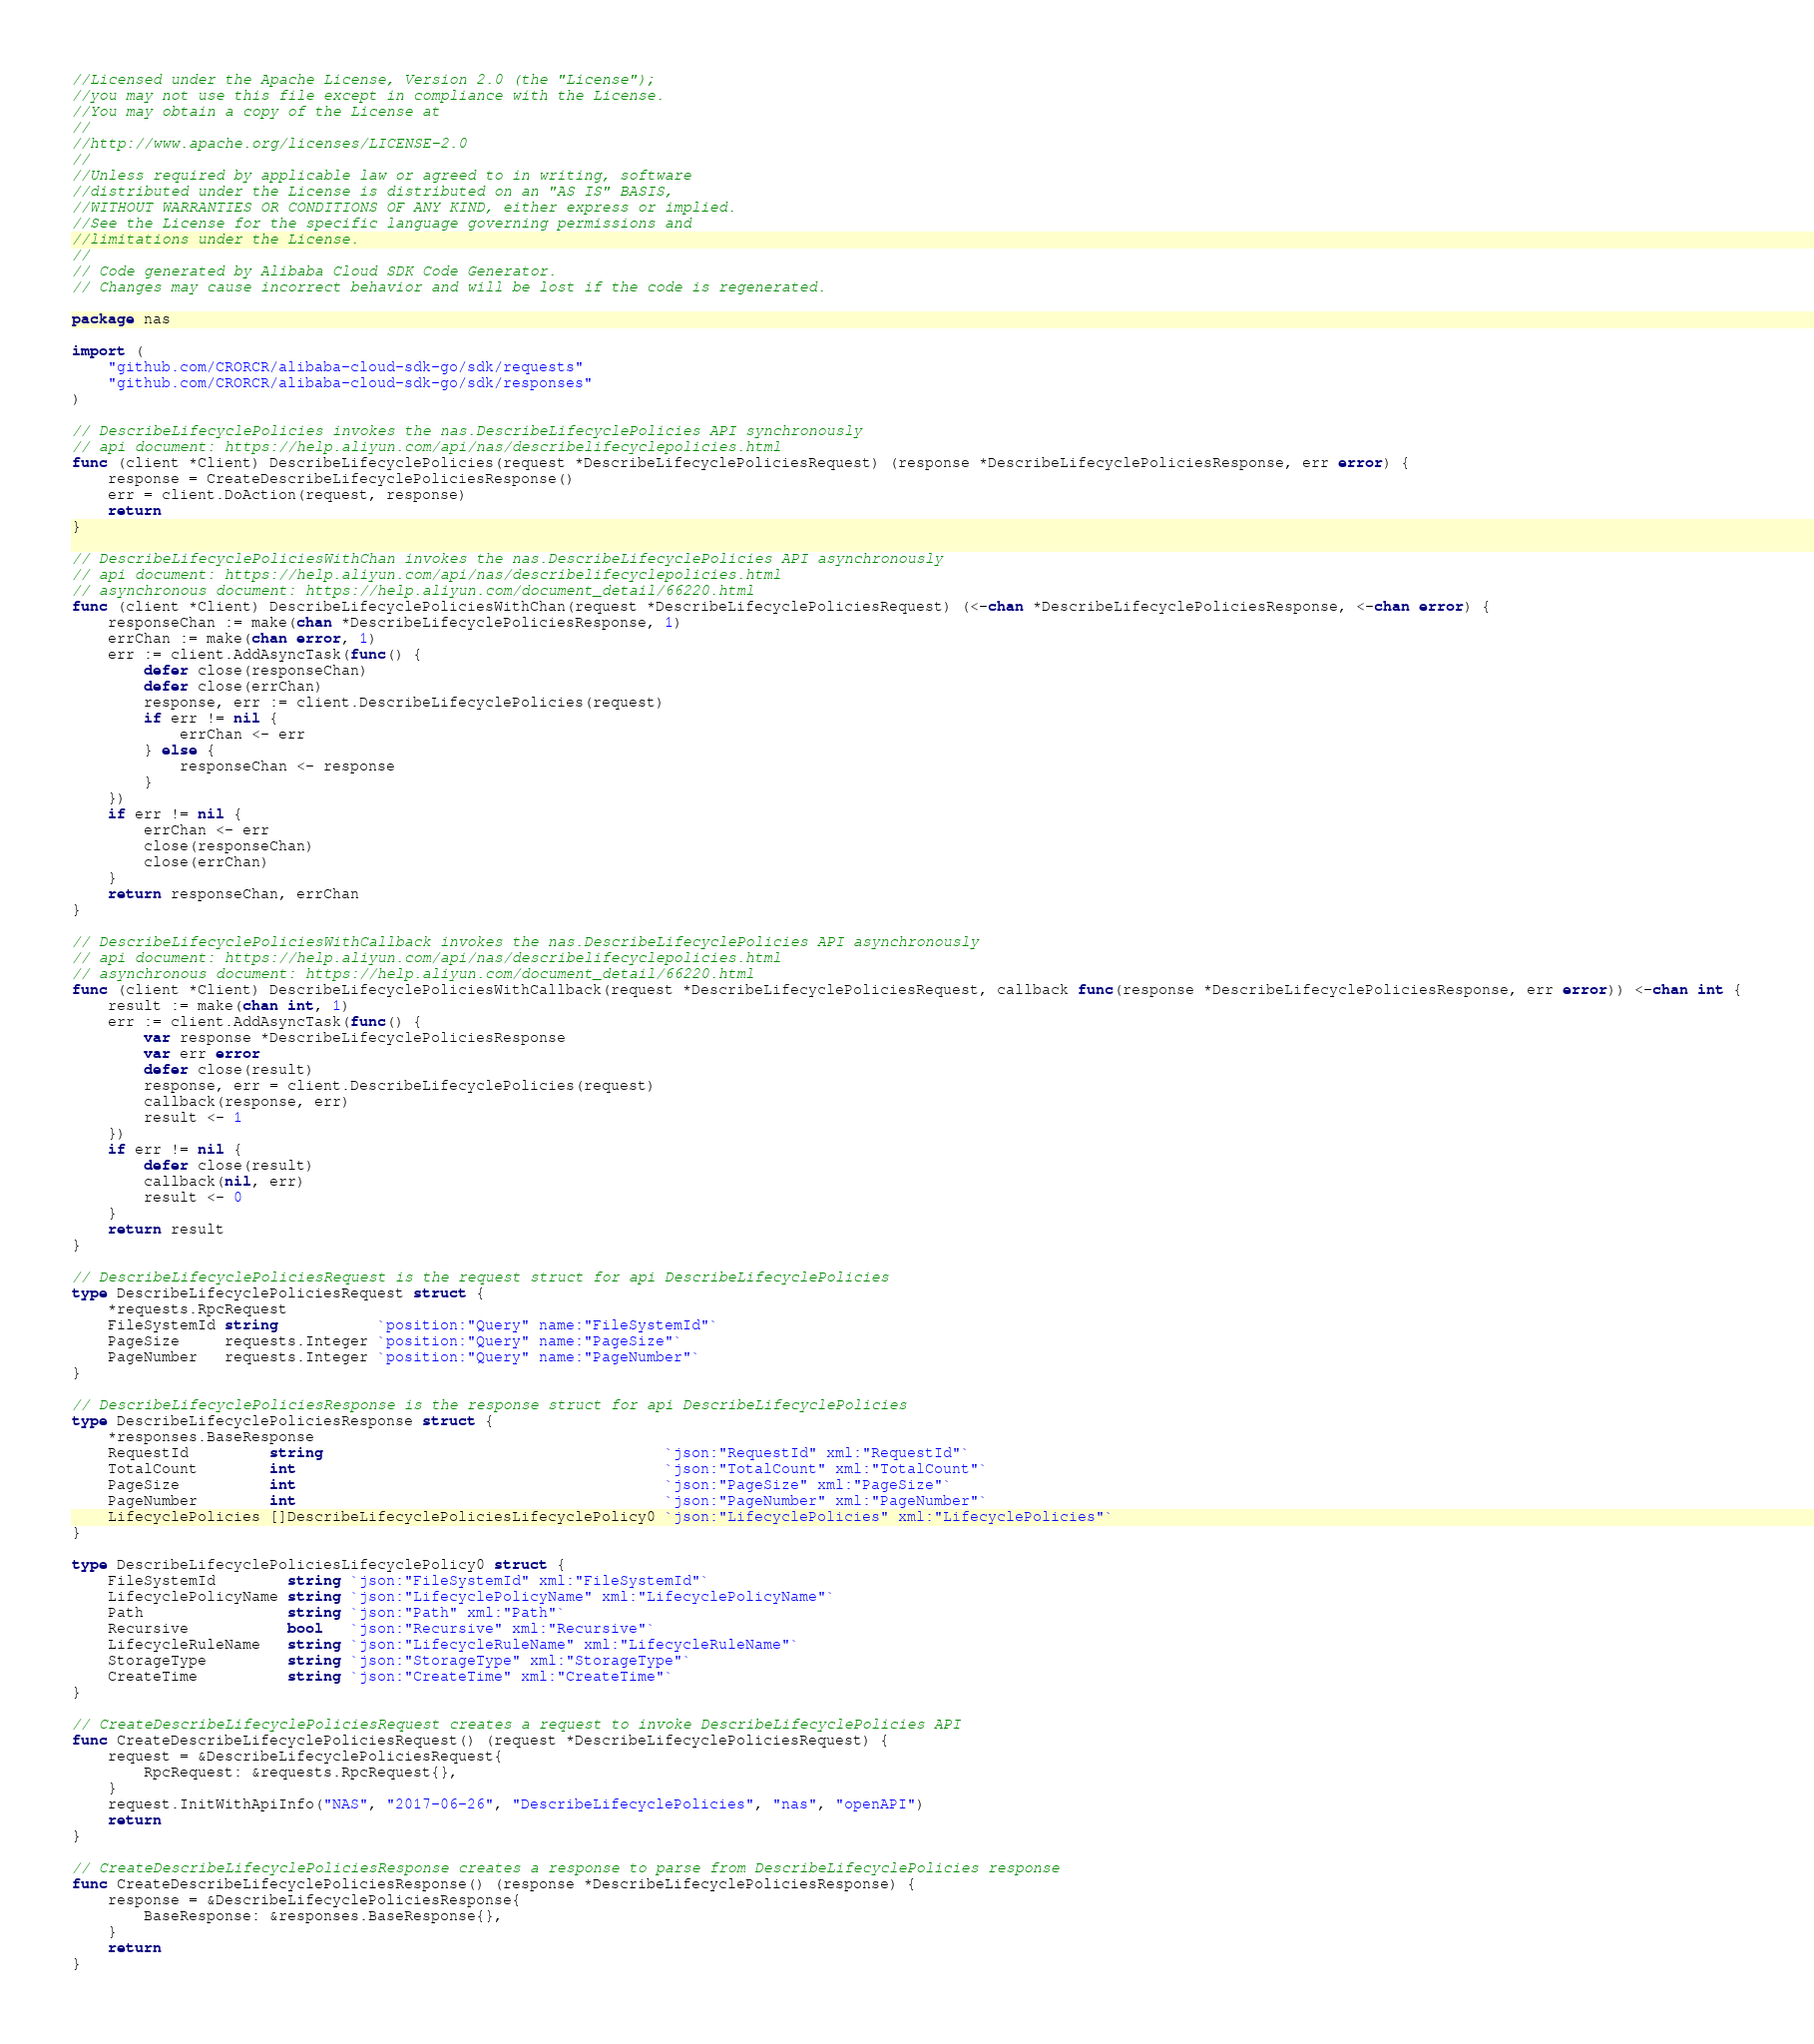Convert code to text. <code><loc_0><loc_0><loc_500><loc_500><_Go_>//Licensed under the Apache License, Version 2.0 (the "License");
//you may not use this file except in compliance with the License.
//You may obtain a copy of the License at
//
//http://www.apache.org/licenses/LICENSE-2.0
//
//Unless required by applicable law or agreed to in writing, software
//distributed under the License is distributed on an "AS IS" BASIS,
//WITHOUT WARRANTIES OR CONDITIONS OF ANY KIND, either express or implied.
//See the License for the specific language governing permissions and
//limitations under the License.
//
// Code generated by Alibaba Cloud SDK Code Generator.
// Changes may cause incorrect behavior and will be lost if the code is regenerated.

package nas

import (
	"github.com/CRORCR/alibaba-cloud-sdk-go/sdk/requests"
	"github.com/CRORCR/alibaba-cloud-sdk-go/sdk/responses"
)

// DescribeLifecyclePolicies invokes the nas.DescribeLifecyclePolicies API synchronously
// api document: https://help.aliyun.com/api/nas/describelifecyclepolicies.html
func (client *Client) DescribeLifecyclePolicies(request *DescribeLifecyclePoliciesRequest) (response *DescribeLifecyclePoliciesResponse, err error) {
	response = CreateDescribeLifecyclePoliciesResponse()
	err = client.DoAction(request, response)
	return
}

// DescribeLifecyclePoliciesWithChan invokes the nas.DescribeLifecyclePolicies API asynchronously
// api document: https://help.aliyun.com/api/nas/describelifecyclepolicies.html
// asynchronous document: https://help.aliyun.com/document_detail/66220.html
func (client *Client) DescribeLifecyclePoliciesWithChan(request *DescribeLifecyclePoliciesRequest) (<-chan *DescribeLifecyclePoliciesResponse, <-chan error) {
	responseChan := make(chan *DescribeLifecyclePoliciesResponse, 1)
	errChan := make(chan error, 1)
	err := client.AddAsyncTask(func() {
		defer close(responseChan)
		defer close(errChan)
		response, err := client.DescribeLifecyclePolicies(request)
		if err != nil {
			errChan <- err
		} else {
			responseChan <- response
		}
	})
	if err != nil {
		errChan <- err
		close(responseChan)
		close(errChan)
	}
	return responseChan, errChan
}

// DescribeLifecyclePoliciesWithCallback invokes the nas.DescribeLifecyclePolicies API asynchronously
// api document: https://help.aliyun.com/api/nas/describelifecyclepolicies.html
// asynchronous document: https://help.aliyun.com/document_detail/66220.html
func (client *Client) DescribeLifecyclePoliciesWithCallback(request *DescribeLifecyclePoliciesRequest, callback func(response *DescribeLifecyclePoliciesResponse, err error)) <-chan int {
	result := make(chan int, 1)
	err := client.AddAsyncTask(func() {
		var response *DescribeLifecyclePoliciesResponse
		var err error
		defer close(result)
		response, err = client.DescribeLifecyclePolicies(request)
		callback(response, err)
		result <- 1
	})
	if err != nil {
		defer close(result)
		callback(nil, err)
		result <- 0
	}
	return result
}

// DescribeLifecyclePoliciesRequest is the request struct for api DescribeLifecyclePolicies
type DescribeLifecyclePoliciesRequest struct {
	*requests.RpcRequest
	FileSystemId string           `position:"Query" name:"FileSystemId"`
	PageSize     requests.Integer `position:"Query" name:"PageSize"`
	PageNumber   requests.Integer `position:"Query" name:"PageNumber"`
}

// DescribeLifecyclePoliciesResponse is the response struct for api DescribeLifecyclePolicies
type DescribeLifecyclePoliciesResponse struct {
	*responses.BaseResponse
	RequestId         string                                      `json:"RequestId" xml:"RequestId"`
	TotalCount        int                                         `json:"TotalCount" xml:"TotalCount"`
	PageSize          int                                         `json:"PageSize" xml:"PageSize"`
	PageNumber        int                                         `json:"PageNumber" xml:"PageNumber"`
	LifecyclePolicies []DescribeLifecyclePoliciesLifecyclePolicy0 `json:"LifecyclePolicies" xml:"LifecyclePolicies"`
}

type DescribeLifecyclePoliciesLifecyclePolicy0 struct {
	FileSystemId        string `json:"FileSystemId" xml:"FileSystemId"`
	LifecyclePolicyName string `json:"LifecyclePolicyName" xml:"LifecyclePolicyName"`
	Path                string `json:"Path" xml:"Path"`
	Recursive           bool   `json:"Recursive" xml:"Recursive"`
	LifecycleRuleName   string `json:"LifecycleRuleName" xml:"LifecycleRuleName"`
	StorageType         string `json:"StorageType" xml:"StorageType"`
	CreateTime          string `json:"CreateTime" xml:"CreateTime"`
}

// CreateDescribeLifecyclePoliciesRequest creates a request to invoke DescribeLifecyclePolicies API
func CreateDescribeLifecyclePoliciesRequest() (request *DescribeLifecyclePoliciesRequest) {
	request = &DescribeLifecyclePoliciesRequest{
		RpcRequest: &requests.RpcRequest{},
	}
	request.InitWithApiInfo("NAS", "2017-06-26", "DescribeLifecyclePolicies", "nas", "openAPI")
	return
}

// CreateDescribeLifecyclePoliciesResponse creates a response to parse from DescribeLifecyclePolicies response
func CreateDescribeLifecyclePoliciesResponse() (response *DescribeLifecyclePoliciesResponse) {
	response = &DescribeLifecyclePoliciesResponse{
		BaseResponse: &responses.BaseResponse{},
	}
	return
}
</code> 